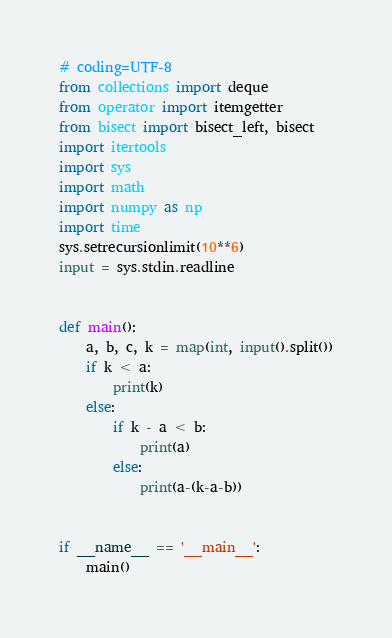<code> <loc_0><loc_0><loc_500><loc_500><_Python_># coding=UTF-8
from collections import deque
from operator import itemgetter
from bisect import bisect_left, bisect
import itertools
import sys
import math
import numpy as np
import time
sys.setrecursionlimit(10**6)
input = sys.stdin.readline


def main():
    a, b, c, k = map(int, input().split())
    if k < a:
        print(k)
    else:
        if k - a < b:
            print(a)
        else:
            print(a-(k-a-b))


if __name__ == '__main__':
    main()
</code> 